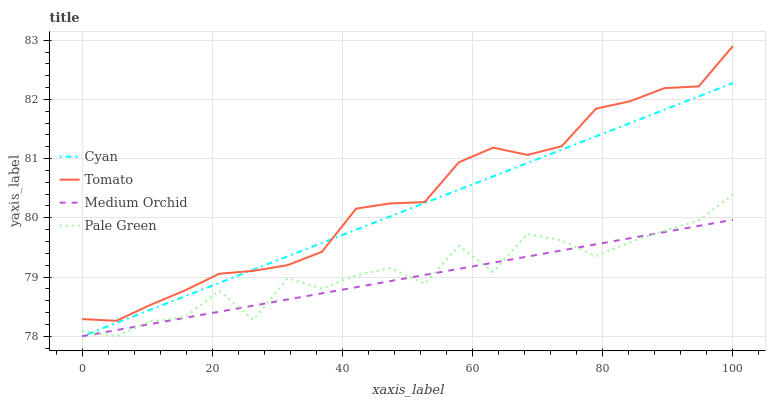Does Cyan have the minimum area under the curve?
Answer yes or no. No. Does Cyan have the maximum area under the curve?
Answer yes or no. No. Is Cyan the smoothest?
Answer yes or no. No. Is Cyan the roughest?
Answer yes or no. No. Does Cyan have the highest value?
Answer yes or no. No. Is Pale Green less than Tomato?
Answer yes or no. Yes. Is Tomato greater than Pale Green?
Answer yes or no. Yes. Does Pale Green intersect Tomato?
Answer yes or no. No. 